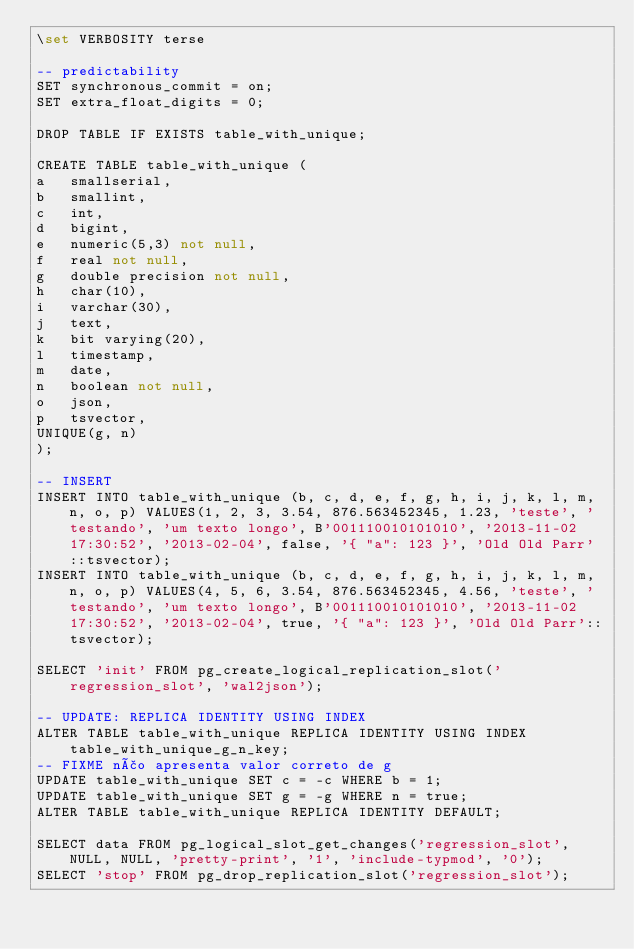Convert code to text. <code><loc_0><loc_0><loc_500><loc_500><_SQL_>\set VERBOSITY terse

-- predictability
SET synchronous_commit = on;
SET extra_float_digits = 0;

DROP TABLE IF EXISTS table_with_unique;

CREATE TABLE table_with_unique (
a	smallserial,
b	smallint,
c	int,
d	bigint,
e	numeric(5,3) not null,
f	real not null,
g	double precision not null,
h	char(10),
i	varchar(30),
j	text,
k	bit varying(20),
l	timestamp,
m	date,
n	boolean not null,
o	json,
p	tsvector,
UNIQUE(g, n)
);

-- INSERT
INSERT INTO table_with_unique (b, c, d, e, f, g, h, i, j, k, l, m, n, o, p) VALUES(1, 2, 3, 3.54, 876.563452345, 1.23, 'teste', 'testando', 'um texto longo', B'001110010101010', '2013-11-02 17:30:52', '2013-02-04', false, '{ "a": 123 }', 'Old Old Parr'::tsvector);
INSERT INTO table_with_unique (b, c, d, e, f, g, h, i, j, k, l, m, n, o, p) VALUES(4, 5, 6, 3.54, 876.563452345, 4.56, 'teste', 'testando', 'um texto longo', B'001110010101010', '2013-11-02 17:30:52', '2013-02-04', true, '{ "a": 123 }', 'Old Old Parr'::tsvector);

SELECT 'init' FROM pg_create_logical_replication_slot('regression_slot', 'wal2json');

-- UPDATE: REPLICA IDENTITY USING INDEX
ALTER TABLE table_with_unique REPLICA IDENTITY USING INDEX table_with_unique_g_n_key;
-- FIXME não apresenta valor correto de g
UPDATE table_with_unique SET c = -c WHERE b = 1;
UPDATE table_with_unique SET g = -g WHERE n = true;
ALTER TABLE table_with_unique REPLICA IDENTITY DEFAULT;

SELECT data FROM pg_logical_slot_get_changes('regression_slot', NULL, NULL, 'pretty-print', '1', 'include-typmod', '0');
SELECT 'stop' FROM pg_drop_replication_slot('regression_slot');
</code> 